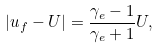<formula> <loc_0><loc_0><loc_500><loc_500>| u _ { f } - U | = \frac { \gamma _ { e } - 1 } { \gamma _ { e } + 1 } U ,</formula> 